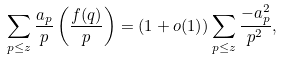<formula> <loc_0><loc_0><loc_500><loc_500>\sum _ { p \leq z } \frac { a _ { p } } { p } \left ( \frac { f ( q ) } { p } \right ) = ( 1 + o ( 1 ) ) \sum _ { p \leq z } \frac { - a _ { p } ^ { 2 } } { p ^ { 2 } } ,</formula> 